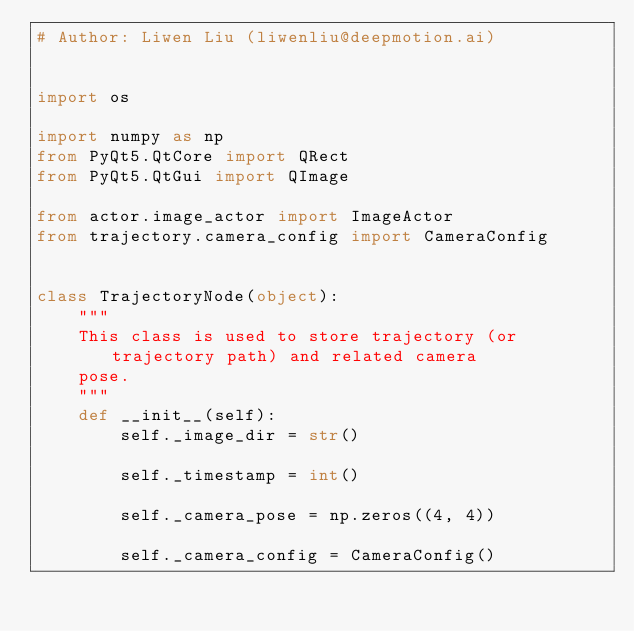<code> <loc_0><loc_0><loc_500><loc_500><_Python_># Author: Liwen Liu (liwenliu@deepmotion.ai)


import os

import numpy as np
from PyQt5.QtCore import QRect
from PyQt5.QtGui import QImage

from actor.image_actor import ImageActor
from trajectory.camera_config import CameraConfig


class TrajectoryNode(object):
    """
    This class is used to store trajectory (or trajectory path) and related camera
    pose.
    """
    def __init__(self):
        self._image_dir = str()

        self._timestamp = int()

        self._camera_pose = np.zeros((4, 4))

        self._camera_config = CameraConfig()
</code> 